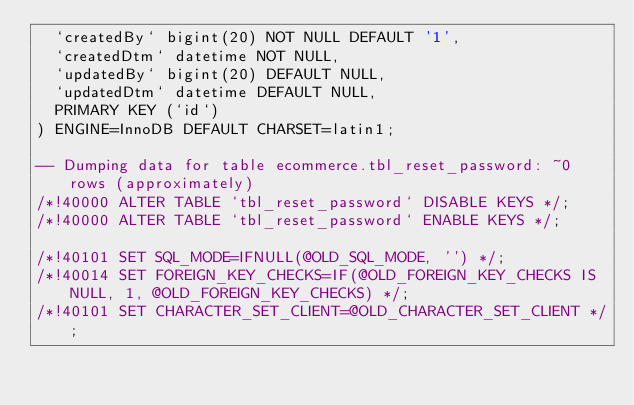Convert code to text. <code><loc_0><loc_0><loc_500><loc_500><_SQL_>  `createdBy` bigint(20) NOT NULL DEFAULT '1',
  `createdDtm` datetime NOT NULL,
  `updatedBy` bigint(20) DEFAULT NULL,
  `updatedDtm` datetime DEFAULT NULL,
  PRIMARY KEY (`id`)
) ENGINE=InnoDB DEFAULT CHARSET=latin1;

-- Dumping data for table ecommerce.tbl_reset_password: ~0 rows (approximately)
/*!40000 ALTER TABLE `tbl_reset_password` DISABLE KEYS */;
/*!40000 ALTER TABLE `tbl_reset_password` ENABLE KEYS */;

/*!40101 SET SQL_MODE=IFNULL(@OLD_SQL_MODE, '') */;
/*!40014 SET FOREIGN_KEY_CHECKS=IF(@OLD_FOREIGN_KEY_CHECKS IS NULL, 1, @OLD_FOREIGN_KEY_CHECKS) */;
/*!40101 SET CHARACTER_SET_CLIENT=@OLD_CHARACTER_SET_CLIENT */;
</code> 